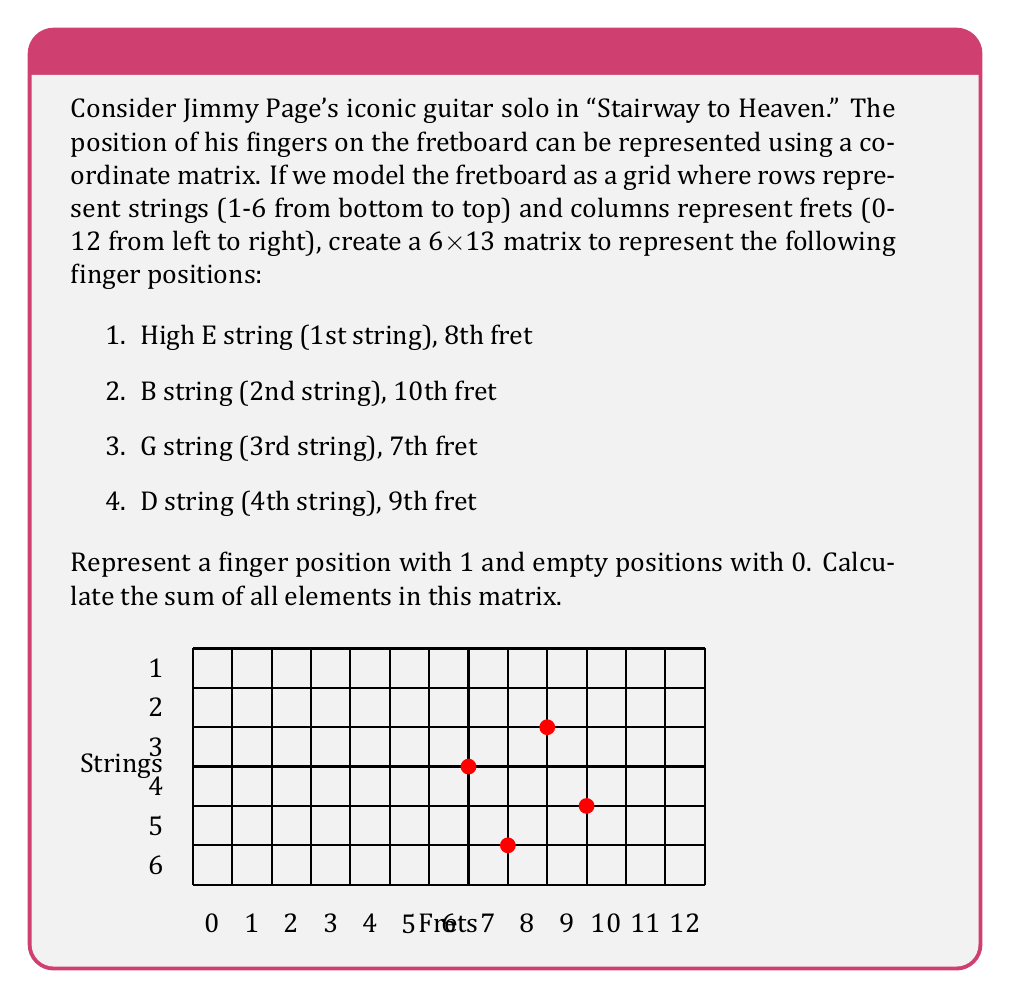Help me with this question. Let's approach this step-by-step:

1) First, we need to create a 6x13 matrix filled with zeros:

   $$M = \begin{bmatrix}
   0 & 0 & 0 & 0 & 0 & 0 & 0 & 0 & 0 & 0 & 0 & 0 & 0 \\
   0 & 0 & 0 & 0 & 0 & 0 & 0 & 0 & 0 & 0 & 0 & 0 & 0 \\
   0 & 0 & 0 & 0 & 0 & 0 & 0 & 0 & 0 & 0 & 0 & 0 & 0 \\
   0 & 0 & 0 & 0 & 0 & 0 & 0 & 0 & 0 & 0 & 0 & 0 & 0 \\
   0 & 0 & 0 & 0 & 0 & 0 & 0 & 0 & 0 & 0 & 0 & 0 & 0 \\
   0 & 0 & 0 & 0 & 0 & 0 & 0 & 0 & 0 & 0 & 0 & 0 & 0
   \end{bmatrix}$$

2) Now, we need to place 1s in the positions corresponding to finger placements:
   - High E string (1st string), 8th fret: $M_{6,9} = 1$
   - B string (2nd string), 10th fret: $M_{5,11} = 1$
   - G string (3rd string), 7th fret: $M_{4,8} = 1$
   - D string (4th string), 9th fret: $M_{3,10} = 1$

3) After placing these 1s, our matrix looks like this:

   $$M = \begin{bmatrix}
   0 & 0 & 0 & 0 & 0 & 0 & 0 & 0 & 0 & 0 & 0 & 0 & 0 \\
   0 & 0 & 0 & 0 & 0 & 0 & 0 & 0 & 0 & 0 & 0 & 0 & 0 \\
   0 & 0 & 0 & 0 & 0 & 0 & 0 & 0 & 0 & 1 & 0 & 0 & 0 \\
   0 & 0 & 0 & 0 & 0 & 0 & 0 & 1 & 0 & 0 & 0 & 0 & 0 \\
   0 & 0 & 0 & 0 & 0 & 0 & 0 & 0 & 0 & 0 & 1 & 0 & 0 \\
   0 & 0 & 0 & 0 & 0 & 0 & 0 & 0 & 1 & 0 & 0 & 0 & 0
   \end{bmatrix}$$

4) To find the sum of all elements, we simply need to count the number of 1s in the matrix.

5) There are four 1s in the matrix, corresponding to the four finger positions given.

Therefore, the sum of all elements in the matrix is 4.
Answer: 4 